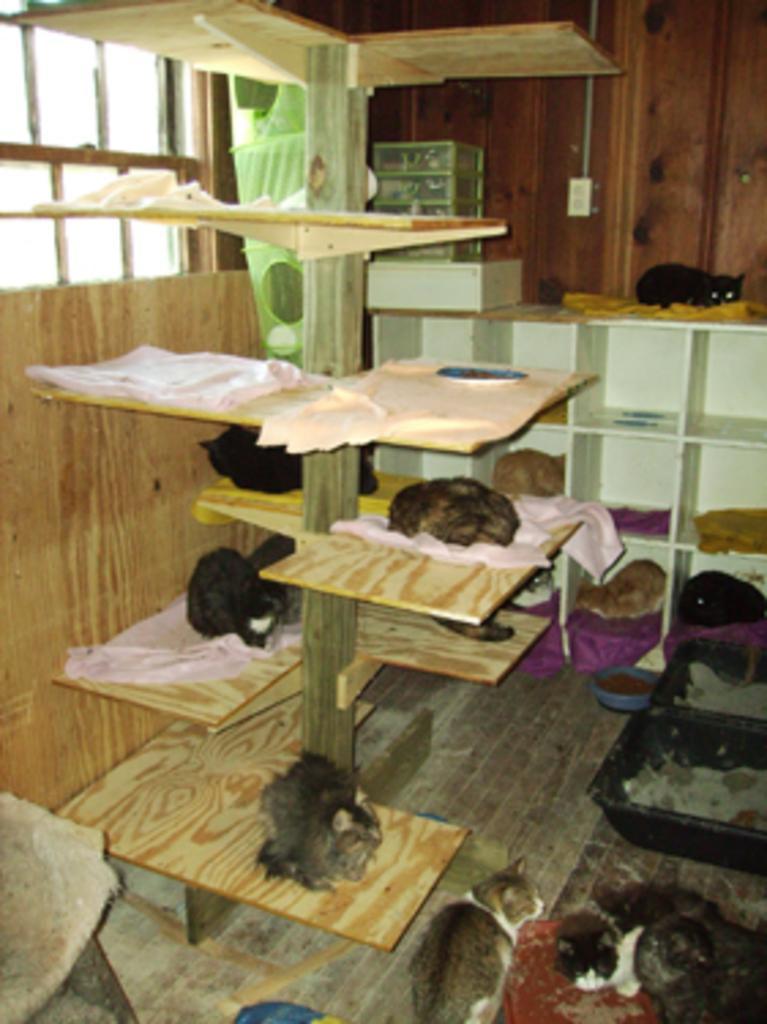How would you summarize this image in a sentence or two? In this image there are cats everywhere in a room, there are baskets, cupboards, wooden pole with shelves and some other objects, in the background of the image there is a wooden wall with electrical switches and glass windows. 